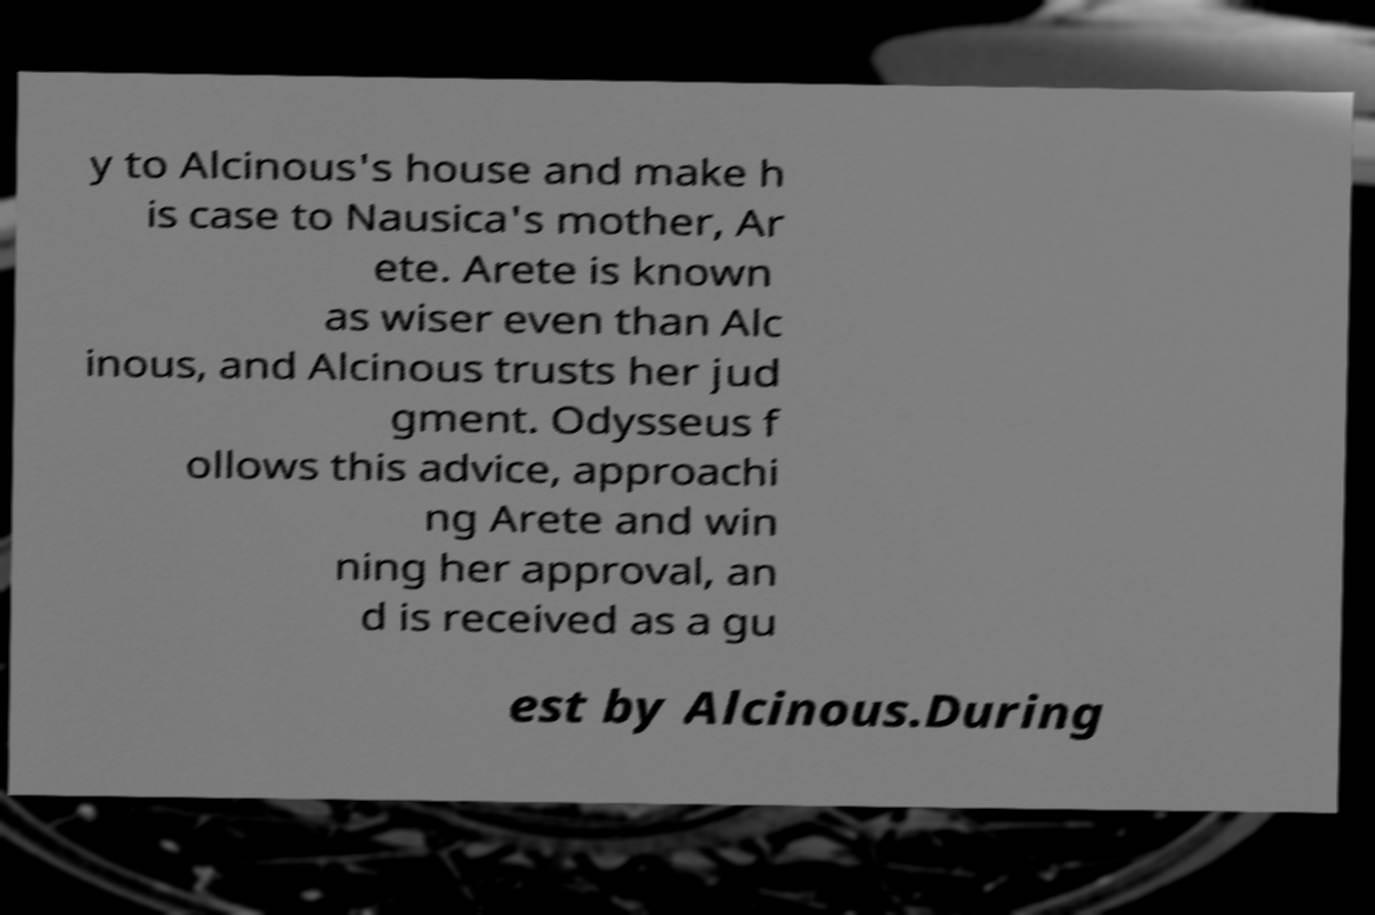For documentation purposes, I need the text within this image transcribed. Could you provide that? y to Alcinous's house and make h is case to Nausica's mother, Ar ete. Arete is known as wiser even than Alc inous, and Alcinous trusts her jud gment. Odysseus f ollows this advice, approachi ng Arete and win ning her approval, an d is received as a gu est by Alcinous.During 